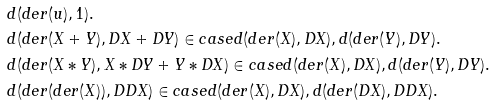<formula> <loc_0><loc_0><loc_500><loc_500>& d ( d e r ( u ) , 1 ) . \\ & d ( d e r ( X + Y ) , D X + D Y ) \in c a s e d ( d e r ( X ) , D X ) , d ( d e r ( Y ) , D Y ) . \\ & d ( d e r ( X * Y ) , X * D Y + Y * D X ) \in c a s e d ( d e r ( X ) , D X ) , d ( d e r ( Y ) , D Y ) . \\ & d ( d e r ( d e r ( X ) ) , D D X ) \in c a s e d ( d e r ( X ) , D X ) , d ( d e r ( D X ) , D D X ) .</formula> 